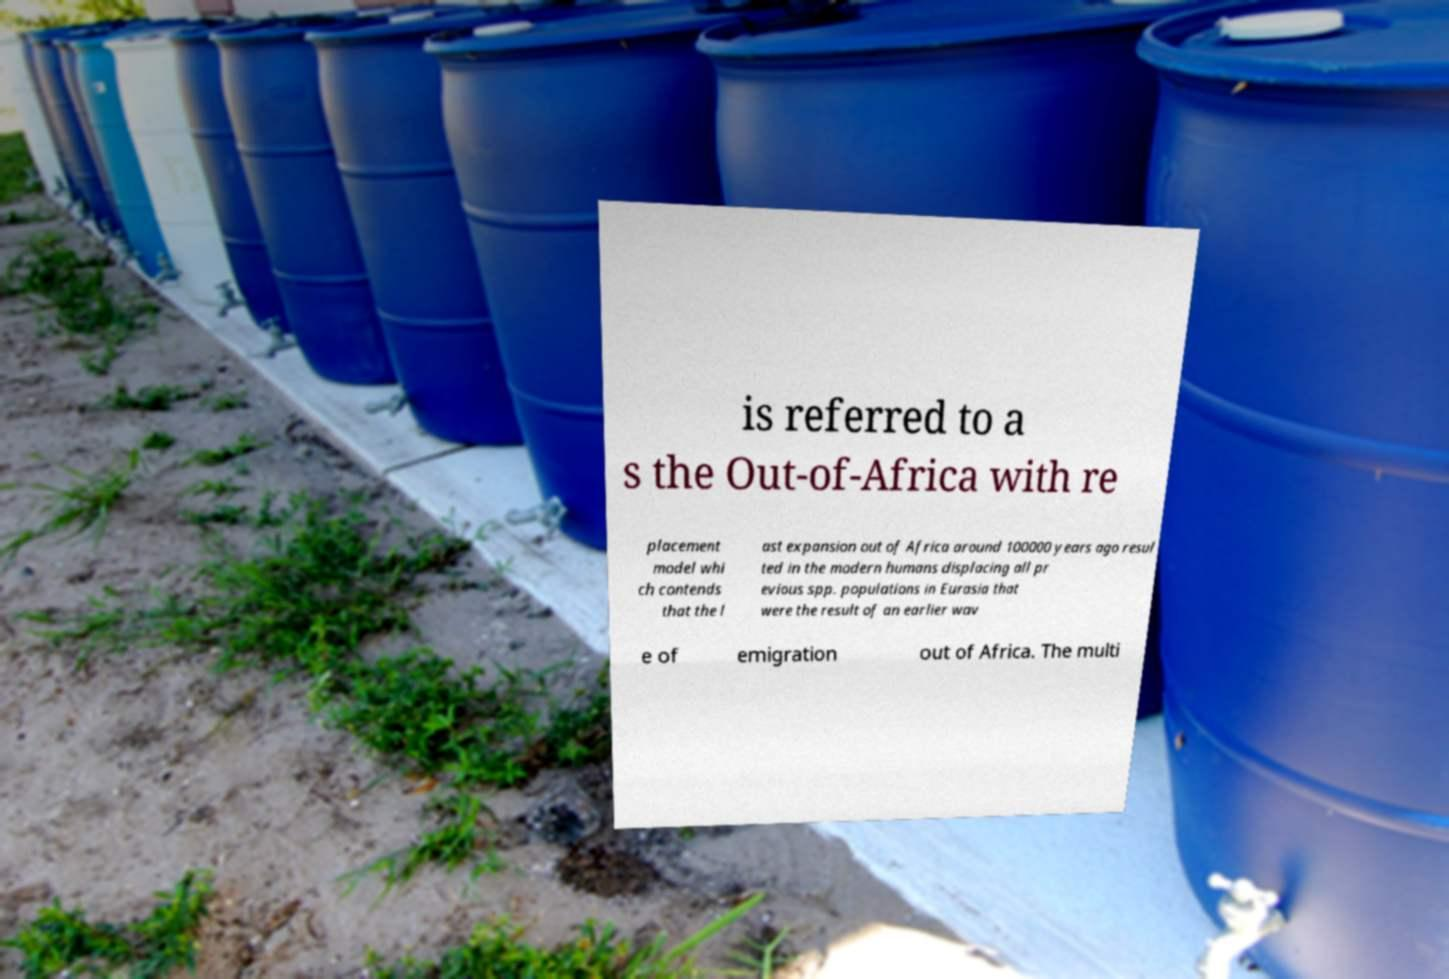There's text embedded in this image that I need extracted. Can you transcribe it verbatim? is referred to a s the Out-of-Africa with re placement model whi ch contends that the l ast expansion out of Africa around 100000 years ago resul ted in the modern humans displacing all pr evious spp. populations in Eurasia that were the result of an earlier wav e of emigration out of Africa. The multi 